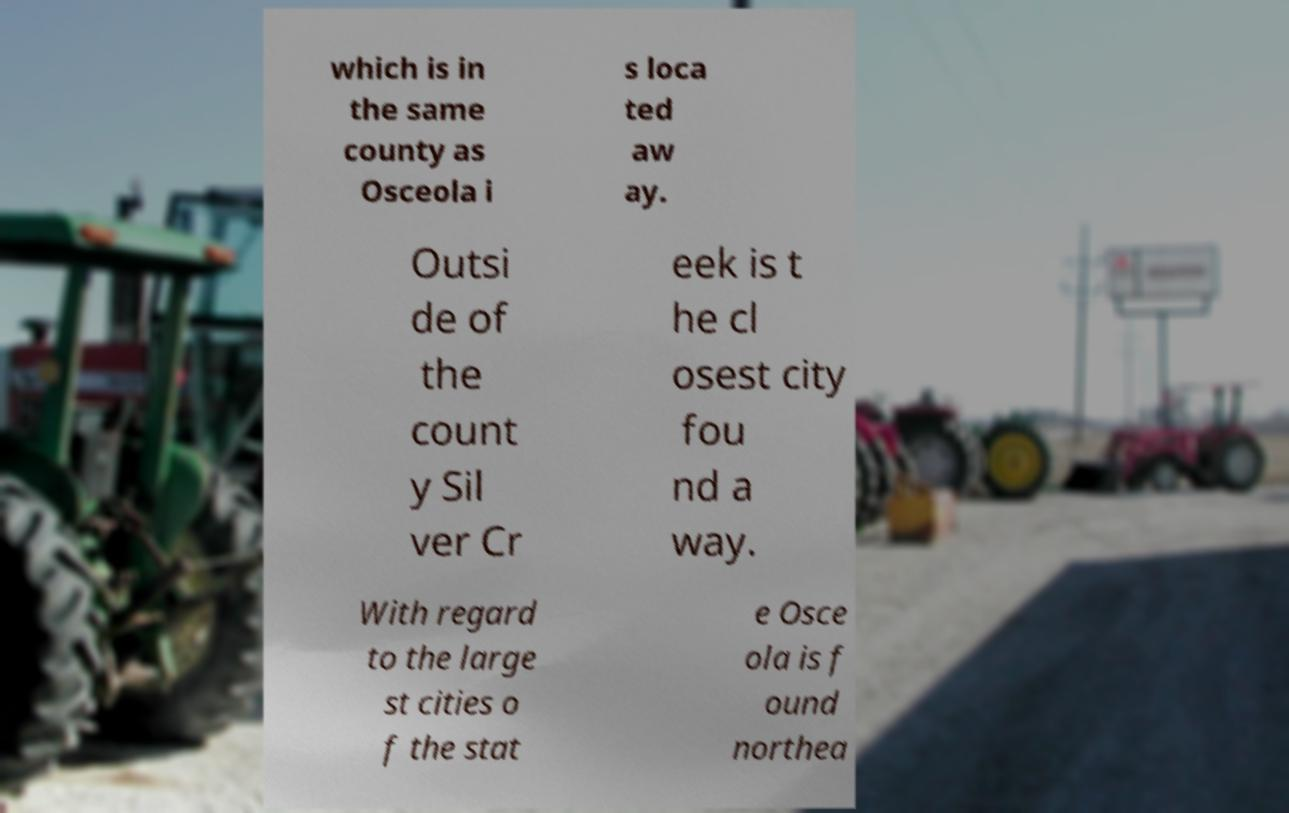Can you accurately transcribe the text from the provided image for me? which is in the same county as Osceola i s loca ted aw ay. Outsi de of the count y Sil ver Cr eek is t he cl osest city fou nd a way. With regard to the large st cities o f the stat e Osce ola is f ound northea 